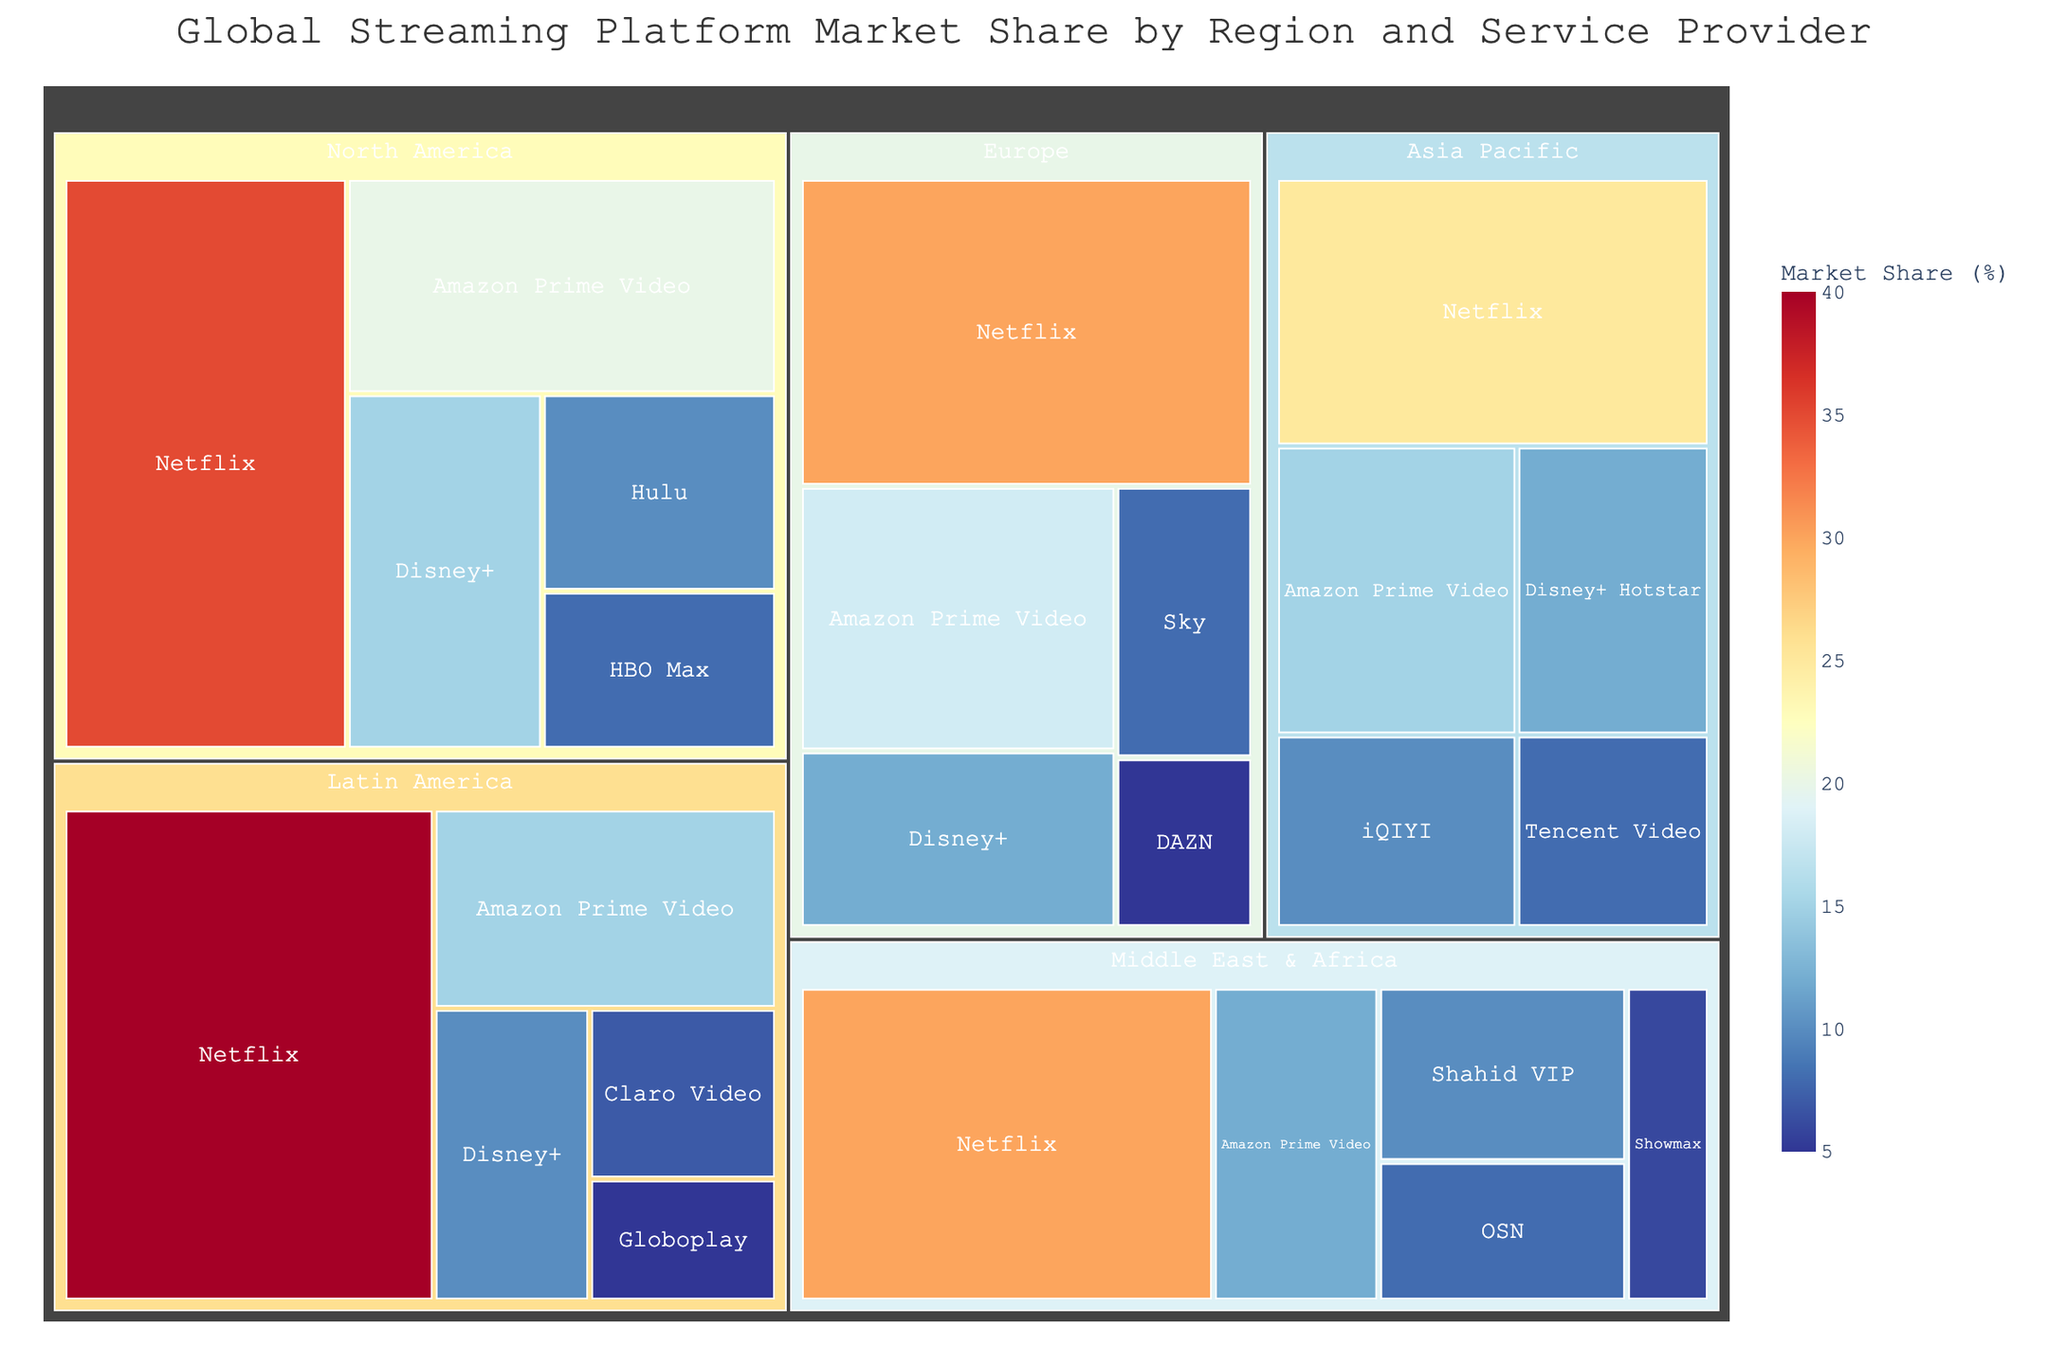what is the overall market share for Netflix across all regions? Sum the market share percentages for Netflix in each region: (35 + 30 + 25 + 40 + 30) = 160%
Answer: 160% Which service provider has the largest market share in North America? Check the service providers listed under the North America region and find the highest value, which is Netflix with 35%
Answer: Netflix How does Amazon Prime Video's market share in Europe compare to its market share in the Middle East & Africa? Compare the market share values for Amazon Prime Video in both regions. Europe has 18%, and Middle East & Africa has 12%
Answer: Europe has a higher market share for Amazon Prime Video What is the combined market share of Disney+ and Disney+ Hotstar in the Asia Pacific region? Add the market share percentages for Disney+ Hotstar (12%) and Disney+ (0%): (12 + 0) = 12%
Answer: 12% Which region has the smallest number of service providers represented in the treemap? Count the number of service providers for each region. The Latin America has 5 represented service providers, which is the lowest
Answer: Latin America What is the total market share for the top two service providers in each region? Identify the top two market share percentages for each region and sum them:
North America: 35% (Netflix) + 20% (Amazon Prime Video) = 55%
Europe: 30% (Netflix) + 18% (Amazon Prime Video) = 48%
Asia Pacific: 25% (Netflix) + 15% (Amazon Prime Video) = 40%
Latin America: 40% (Netflix) + 15% (Amazon Prime Video) = 55%
Middle East & Africa: 30% (Netflix) + 12% (Amazon Prime Video) = 42%
Answer: North America: 55%, Europe: 48%, Asia Pacific: 40%, Latin America: 55%, Middle East & Africa: 42% What is the difference in market share between Netflix and its closest competitor in Latin America? Find Netflix's market share in Latin America (40%) and Amazon Prime Video's (closest competitor, 15%), then calculate the difference: 40% - 15% = 25%
Answer: 25% Which region has the highest market share for a single service provider? Compare the highest market share values of single service providers in each region. Latin America has the highest with 40% for Netflix
Answer: Latin America How many service providers in the Middle East & Africa have a market share of 10% or more? Count the service providers in the Middle East & Africa with a market share of 10% or more: Netflix (30%), Amazon Prime Video (12%), Shahid VIP (10%) – total of 3 providers
Answer: 3 